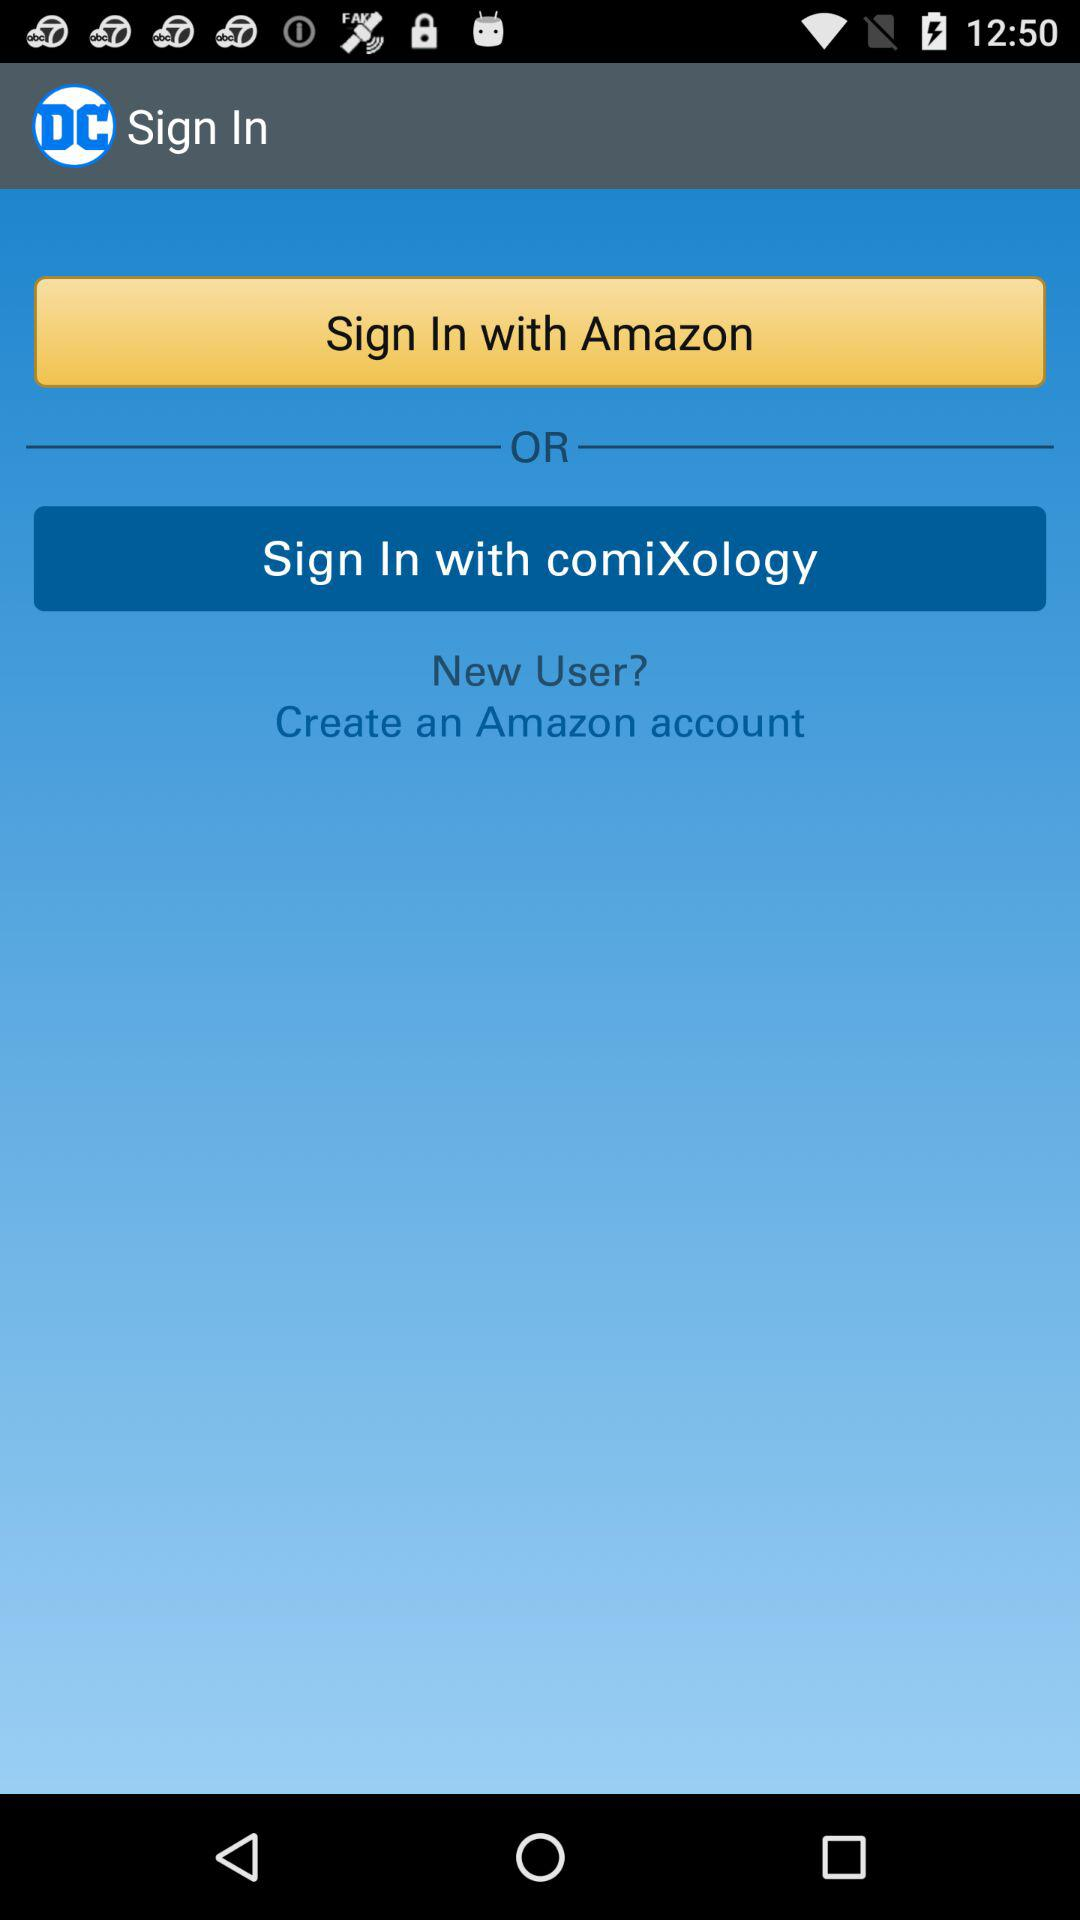How long does it take to sign in with "Amazon"?
When the provided information is insufficient, respond with <no answer>. <no answer> 